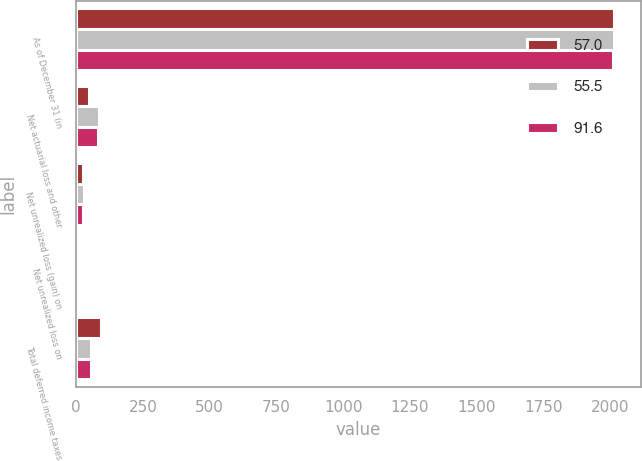Convert chart to OTSL. <chart><loc_0><loc_0><loc_500><loc_500><stacked_bar_chart><ecel><fcel>As of December 31 (in<fcel>Net actuarial loss and other<fcel>Net unrealized loss (gain) on<fcel>Net unrealized loss on<fcel>Total deferred income taxes<nl><fcel>57<fcel>2013<fcel>50<fcel>27.7<fcel>0.2<fcel>91.6<nl><fcel>55.5<fcel>2012<fcel>86.5<fcel>30.4<fcel>0.9<fcel>57<nl><fcel>91.6<fcel>2011<fcel>80.3<fcel>24.9<fcel>0.1<fcel>55.5<nl></chart> 